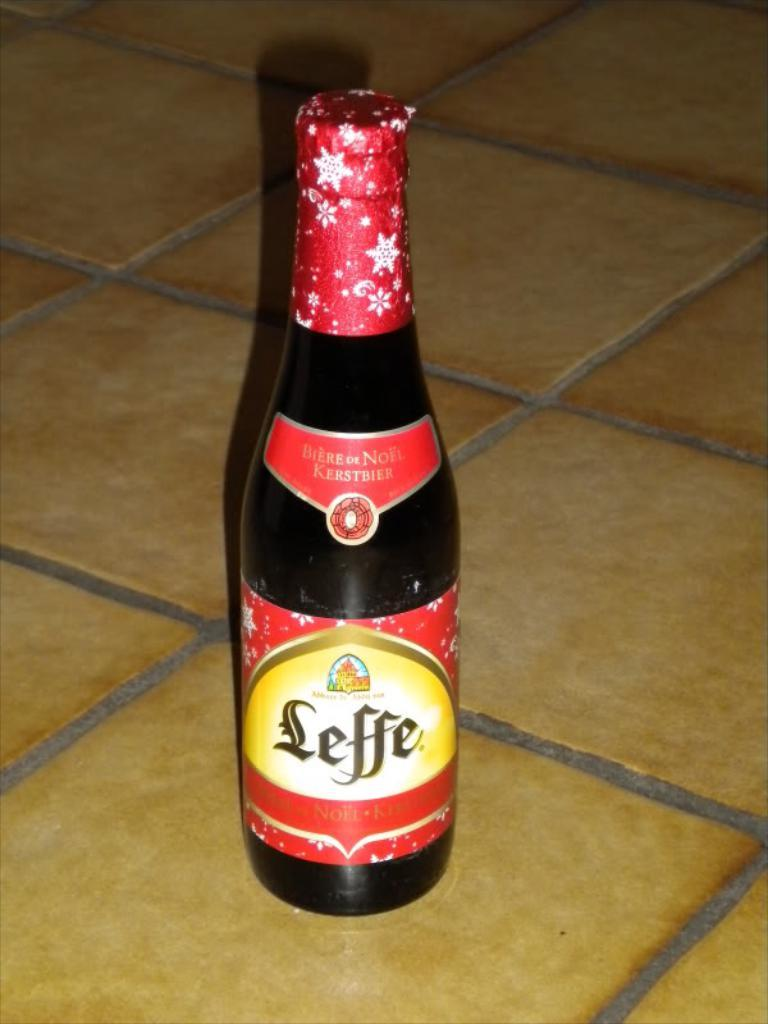<image>
Give a short and clear explanation of the subsequent image. A bottle of Leffe is sitting on a tile flor. 